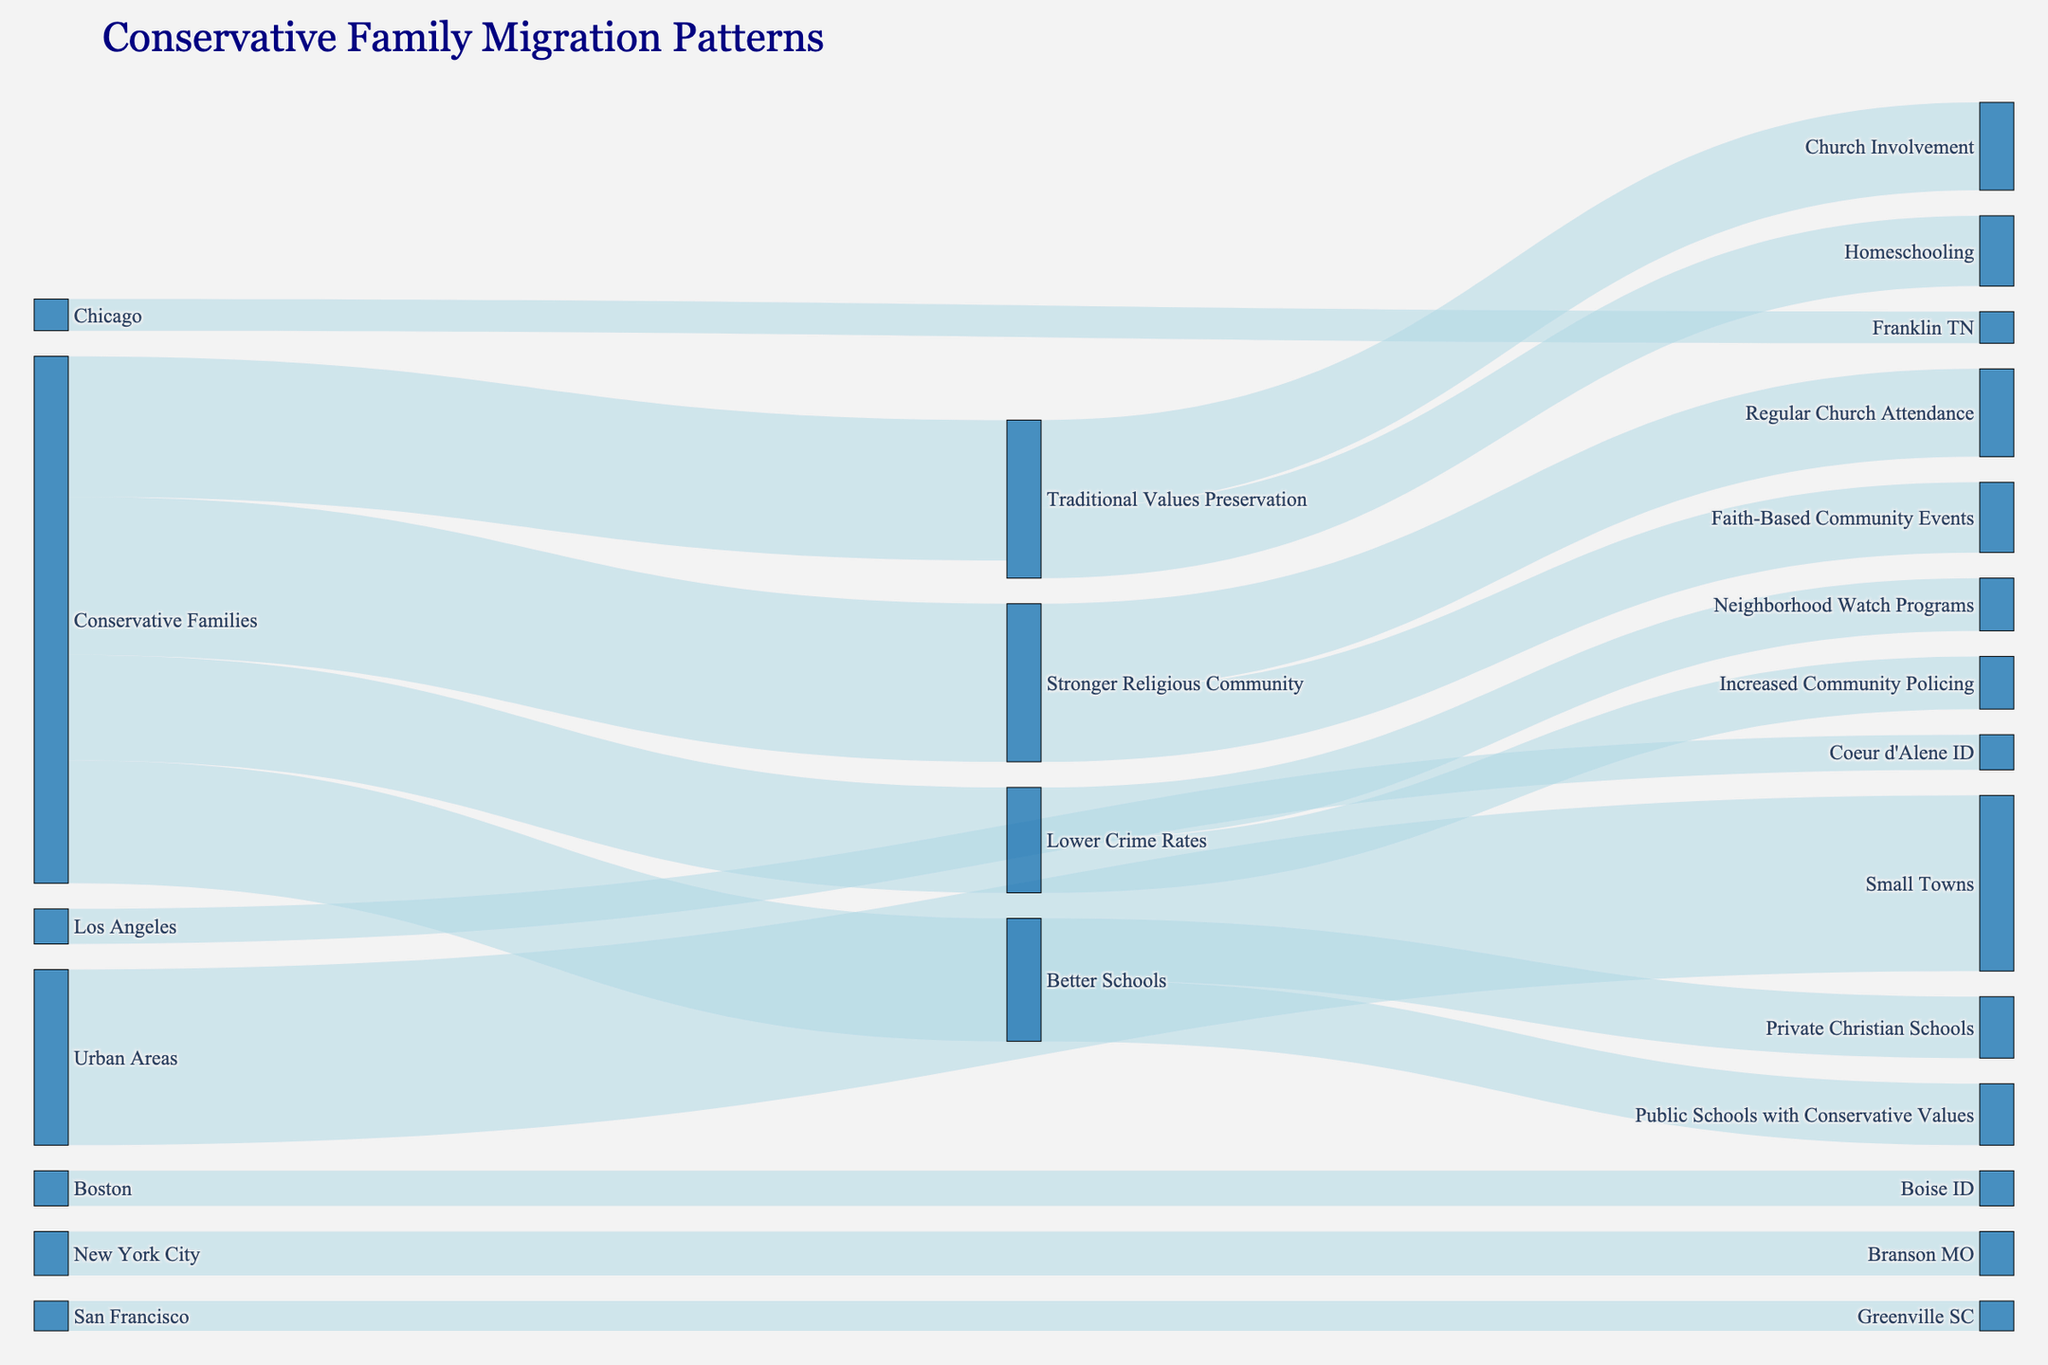What is the overall title of the figure? Look at the top of the chart where the title is typically placed in larger font. The title should summarize the contents of the visual.
Answer: Conservative Family Migration Patterns How many families moved from urban areas to small towns in total? Identify the link connecting "Urban Areas" to "Small Towns" and check the numerical value associated with this link.
Answer: 10,000 Which city had the largest number of families moving to a specific small town? Observe the links from each city (New York City, Los Angeles, Chicago, San Francisco, Boston) to their respective small towns and identify the one with the highest value.
Answer: New York City to Branson MO What is the combined number of families that moved to Branson MO and Coeur d'Alene ID? Add the values associated with the links from "New York City" to "Branson MO" and "Los Angeles" to "Coeur d'Alene ID".
Answer: 4,500 Which reason for migration has the highest number of families associated with it? Look at the different links from "Conservative Families" and determine which target receives the most significant value.
Answer: Stronger Religious Community How many families cited "Better Schools" as a reason for moving? Identify the link connecting "Conservative Families" to "Better Schools" and note the value.
Answer: 7,000 What percentage of families moved due to "Lower Crime Rates" compared to those who moved for "Stronger Religious Community"? Compare the values for "Lower Crime Rates" and "Stronger Religious Community," calculating the percentage. (Lower Crime Rates/Stronger Religious Community)*100 = (6000/9000)*100
Answer: 66.67% What is the total number of families involved in traditional values preservation activities (Homeschooling and Church Involvement)? Add the values associated with "Homeschooling" and "Church Involvement" under "Traditional Values Preservation".
Answer: 9,000 Which specific schooling option had an equal number of families choosing it within the "Better Schools" reasons? Look at the two sub-options under "Better Schools" (Private Christian Schools and Public Schools with Conservative Values) and see if any have equal values.
Answer: Private Christian Schools and Public Schools with Conservative Values Was "Neighborhood Watch Programs" or "Increased Community Policing" more popular among those who cited "Lower Crime Rates"? Compare the values associated with "Neighborhood Watch Programs" and "Increased Community Policing" under "Lower Crime Rates".
Answer: Both had the same value 